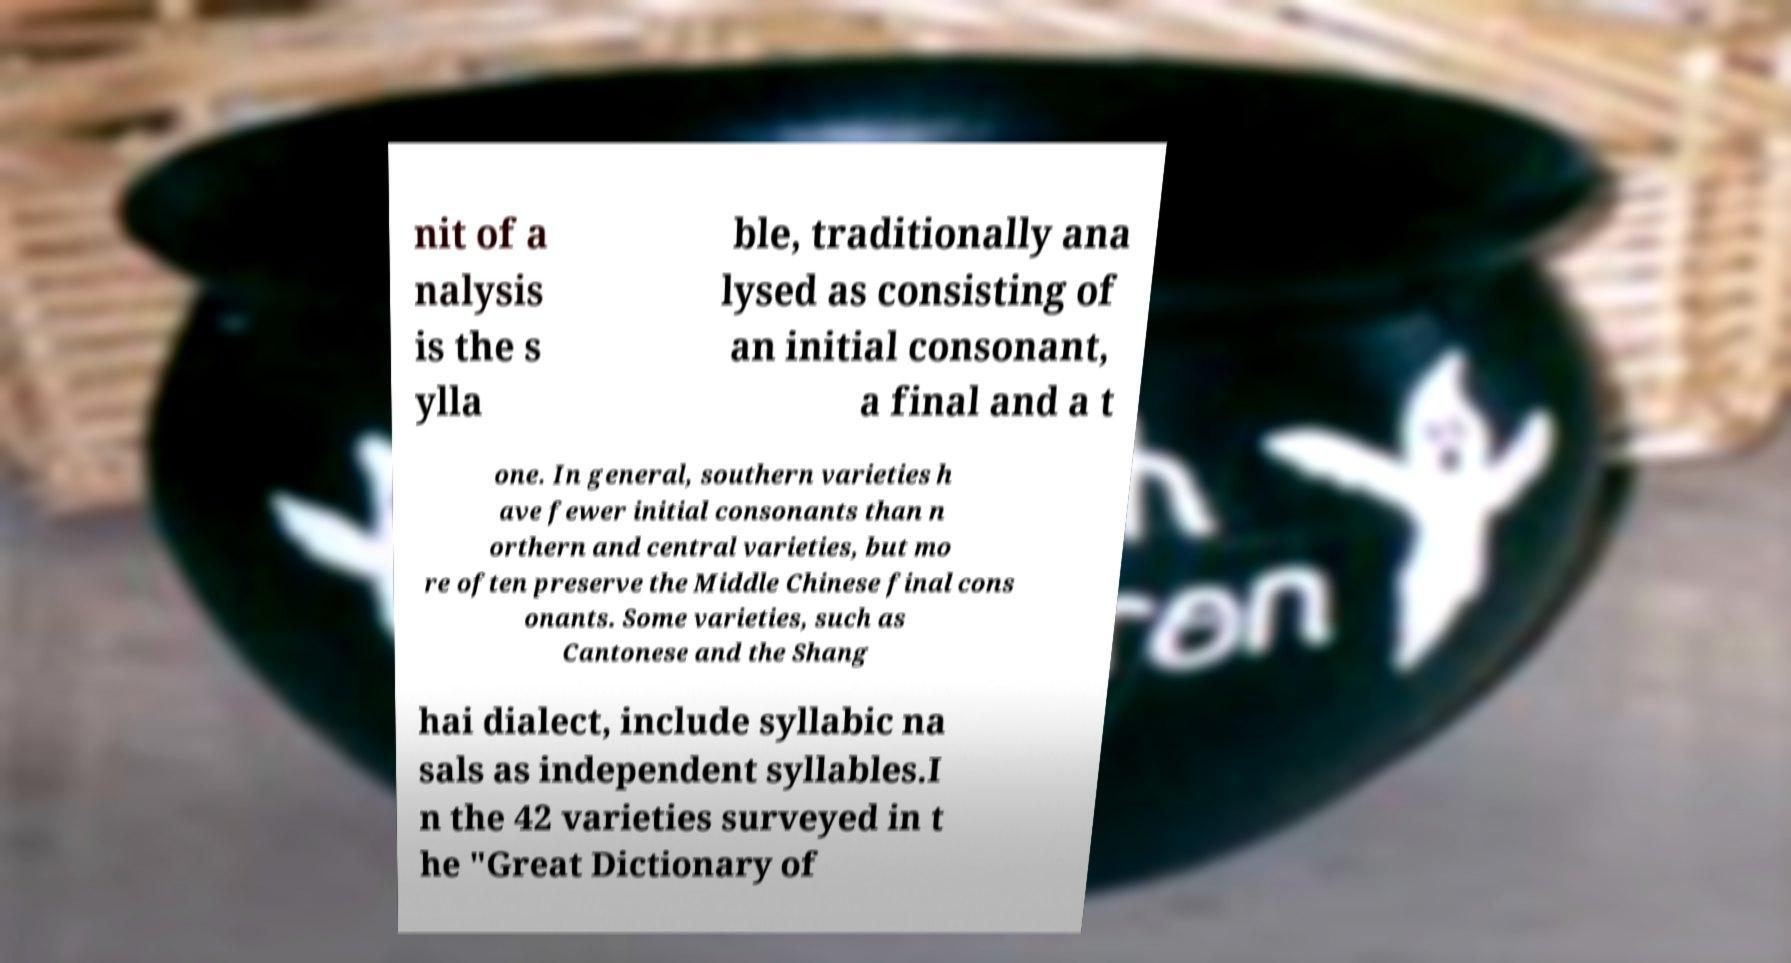Could you extract and type out the text from this image? nit of a nalysis is the s ylla ble, traditionally ana lysed as consisting of an initial consonant, a final and a t one. In general, southern varieties h ave fewer initial consonants than n orthern and central varieties, but mo re often preserve the Middle Chinese final cons onants. Some varieties, such as Cantonese and the Shang hai dialect, include syllabic na sals as independent syllables.I n the 42 varieties surveyed in t he "Great Dictionary of 